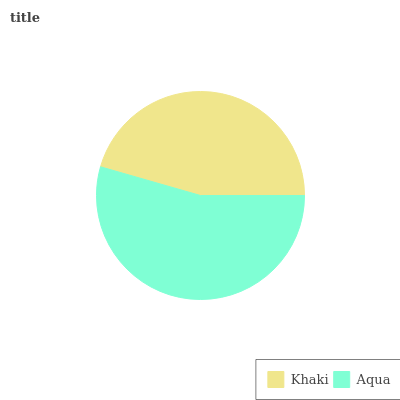Is Khaki the minimum?
Answer yes or no. Yes. Is Aqua the maximum?
Answer yes or no. Yes. Is Aqua the minimum?
Answer yes or no. No. Is Aqua greater than Khaki?
Answer yes or no. Yes. Is Khaki less than Aqua?
Answer yes or no. Yes. Is Khaki greater than Aqua?
Answer yes or no. No. Is Aqua less than Khaki?
Answer yes or no. No. Is Aqua the high median?
Answer yes or no. Yes. Is Khaki the low median?
Answer yes or no. Yes. Is Khaki the high median?
Answer yes or no. No. Is Aqua the low median?
Answer yes or no. No. 